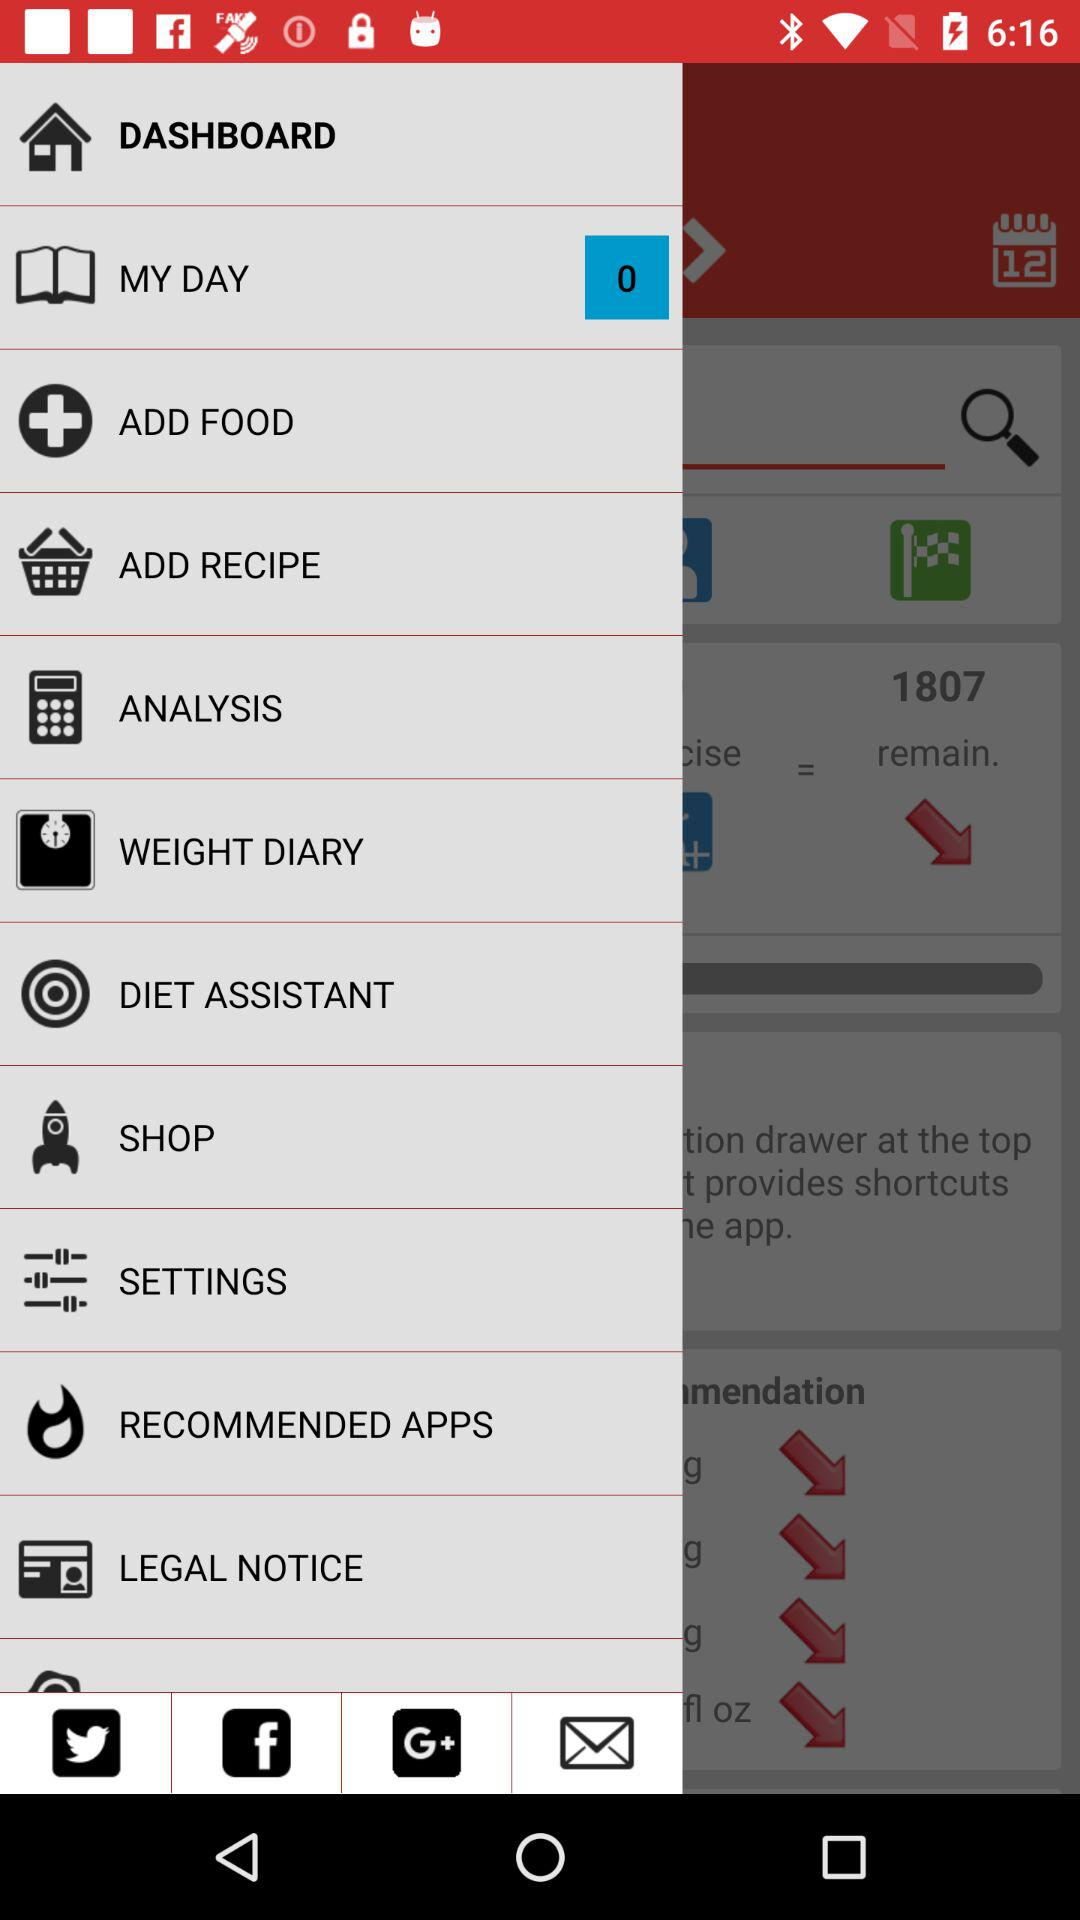Which recipes have been added?
When the provided information is insufficient, respond with <no answer>. <no answer> 